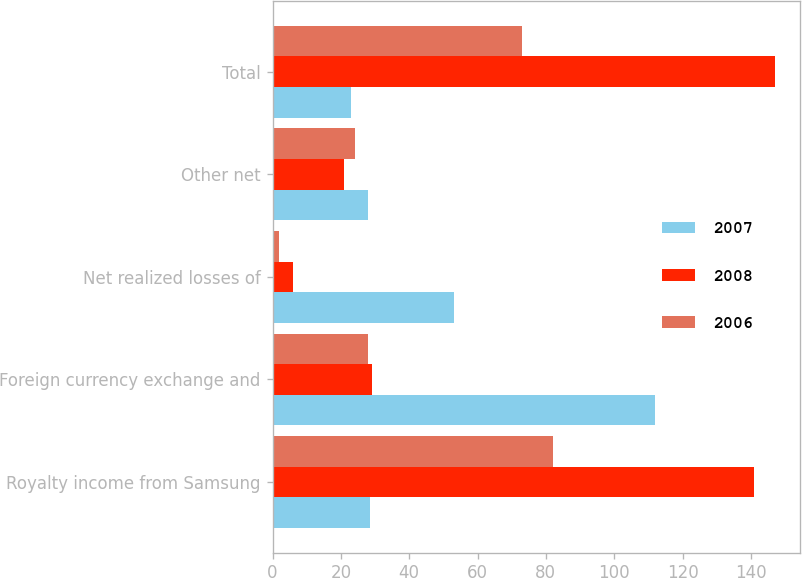Convert chart. <chart><loc_0><loc_0><loc_500><loc_500><stacked_bar_chart><ecel><fcel>Royalty income from Samsung<fcel>Foreign currency exchange and<fcel>Net realized losses of<fcel>Other net<fcel>Total<nl><fcel>2007<fcel>28.5<fcel>112<fcel>53<fcel>28<fcel>23<nl><fcel>2008<fcel>141<fcel>29<fcel>6<fcel>21<fcel>147<nl><fcel>2006<fcel>82<fcel>28<fcel>2<fcel>24<fcel>73<nl></chart> 